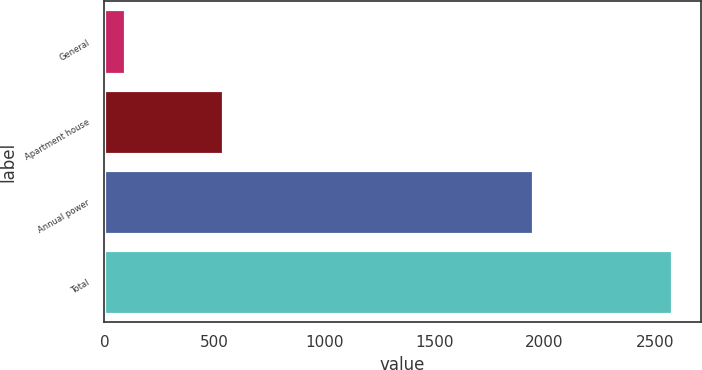<chart> <loc_0><loc_0><loc_500><loc_500><bar_chart><fcel>General<fcel>Apartment house<fcel>Annual power<fcel>Total<nl><fcel>94<fcel>539<fcel>1948<fcel>2581<nl></chart> 